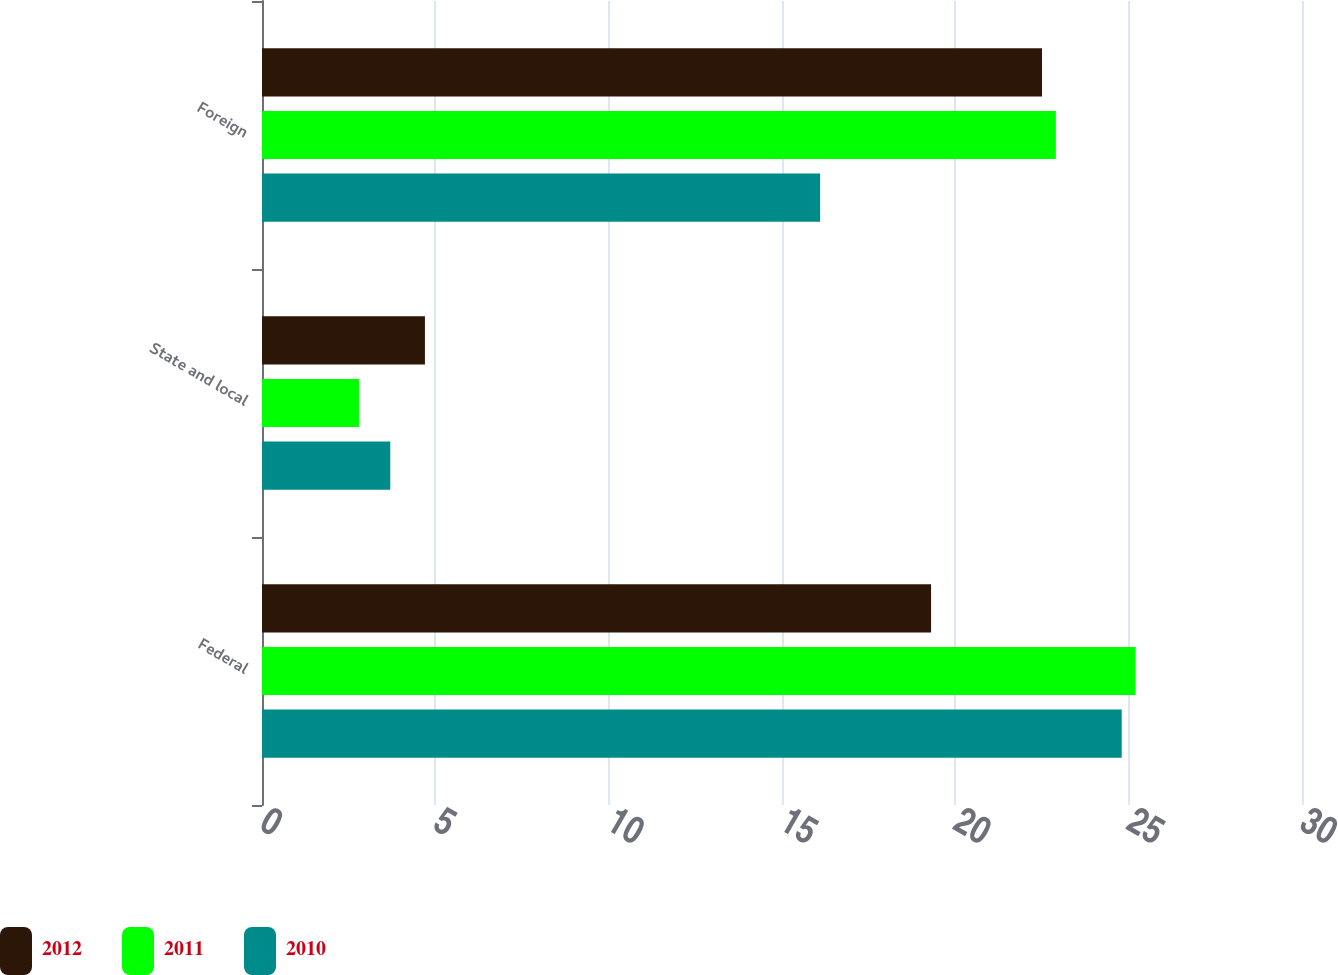Convert chart. <chart><loc_0><loc_0><loc_500><loc_500><stacked_bar_chart><ecel><fcel>Federal<fcel>State and local<fcel>Foreign<nl><fcel>2012<fcel>19.3<fcel>4.7<fcel>22.5<nl><fcel>2011<fcel>25.2<fcel>2.8<fcel>22.9<nl><fcel>2010<fcel>24.8<fcel>3.7<fcel>16.1<nl></chart> 